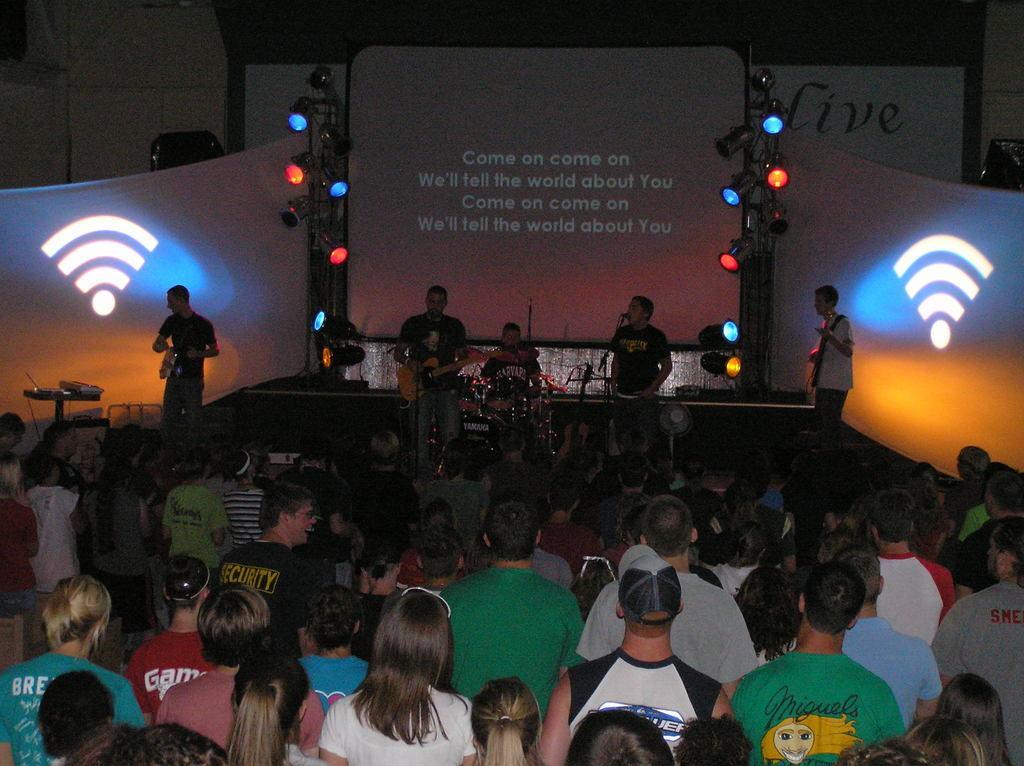Describe this image in one or two sentences. At the top of the image we can see persons standing on the dais and holding musical instruments in their hands. At the bottom of the image we can see persons standing on the floor. 